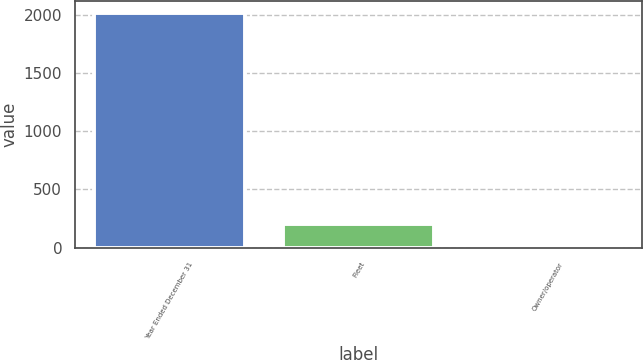Convert chart. <chart><loc_0><loc_0><loc_500><loc_500><bar_chart><fcel>Year Ended December 31<fcel>Fleet<fcel>Owner/operator<nl><fcel>2016<fcel>201.96<fcel>0.4<nl></chart> 